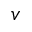Convert formula to latex. <formula><loc_0><loc_0><loc_500><loc_500>v</formula> 